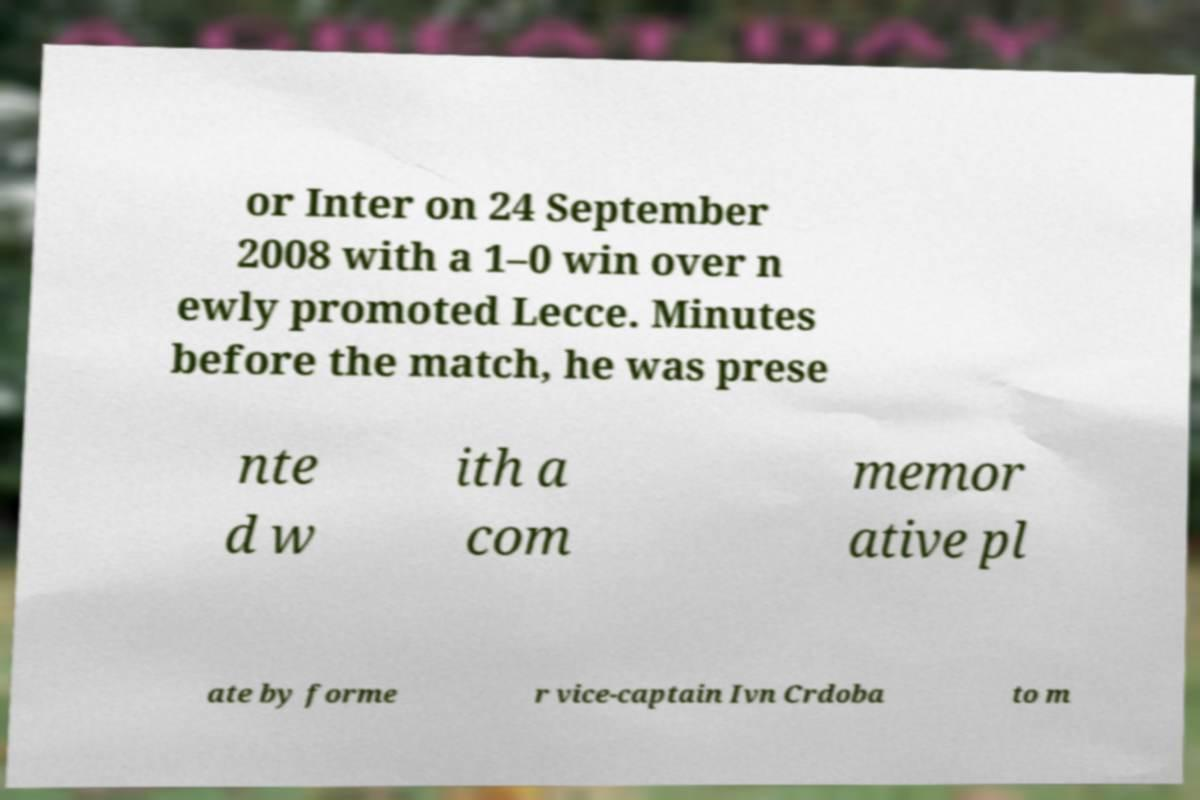For documentation purposes, I need the text within this image transcribed. Could you provide that? or Inter on 24 September 2008 with a 1–0 win over n ewly promoted Lecce. Minutes before the match, he was prese nte d w ith a com memor ative pl ate by forme r vice-captain Ivn Crdoba to m 